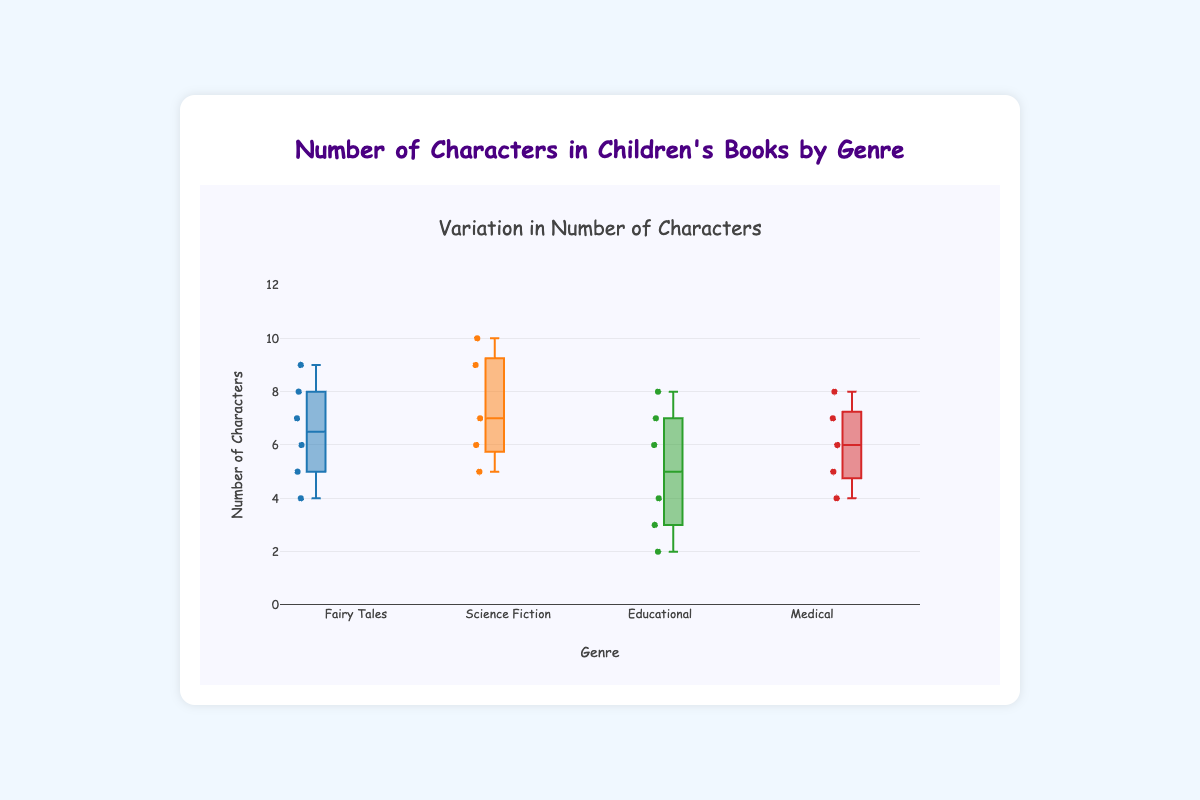How many genres are displayed in the box plot? The title and x-axis labels indication the number of different genres covered in the plot. The x-axis shows the following genres: Fairy Tales, Science Fiction, Educational, and Medical.
Answer: Four What is the maximum number of characters in a book in the Science Fiction genre? By looking at the top of the box plot for the Science Fiction genre, the maximum y-value can be identified. The highest point for Science Fiction books reaches the 10 mark.
Answer: 10 Which genre has the lowest median number of characters? The median of each genre is indicated by the line inside the box. Visual inspection shows that the median line for Educational books is lower than that of Fairy Tales, Science Fiction, and Medical.
Answer: Educational Is the number of characters more varied in Fairy Tales or Medical books? The variation can be assessed by looking at the range and spread of the boxes and whiskers. For Fairy Tales, the range is from 4 to 9 characters, whereas for Medical it is from 4 to 8 characters. Fairy Tales show a slightly larger variation.
Answer: Fairy Tales What is the interquartile range (IQR) of the number of characters in the Educational genre? The IQR is the difference between the 75th percentile (top of the box) and 25th percentile (bottom of the box). Visually identify these boundaries: roughly 7 (top) and 3 (bottom) for Educational genre. Thus, the IQR is 7-3.
Answer: 4 Which genre has the highest median number of characters? The line inside the box represents the median. Comparative inspection shows that the Science Fiction genre's median line is positioned higher than the others.
Answer: Science Fiction What is the range of the number of characters in the Fairy Tales genre? The range is found by subtracting the minimum value (lowest whisker or point) from the maximum value (highest whisker or point). For Fairy Tales, the range is from 4 to 9.
Answer: 5 Are there any outliers in the number of characters data for the Educational genre? Outliers are often shown as points outside the whiskers of the box plot. Inspect the Educational genre's plot for any such points. Here, none are depicted as outliers.
Answer: No Which genre seems to have the least consistent (most varied) number of characters in its books? A more varied or inconsistent genre will have a wider range between its minimum and maximum, and possibly a larger interquartile range (IQR). Fairy Tales exhibit a relatively larger IQR and range compared to the other genres.
Answer: Fairy Tales 